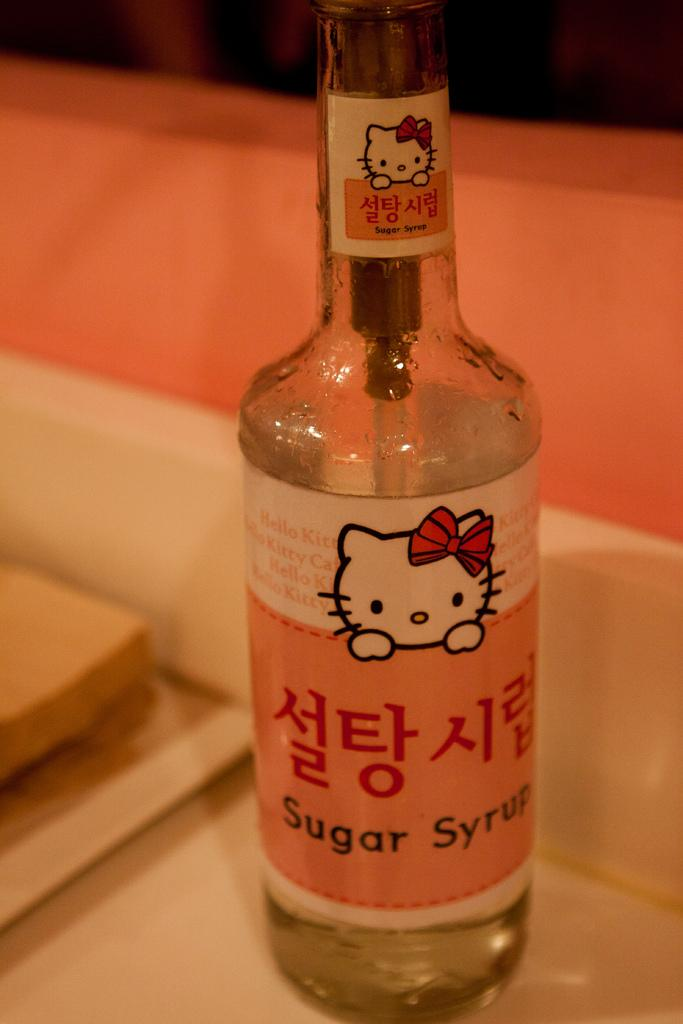Provide a one-sentence caption for the provided image. A clear bottle of sugar syrup with a Hello Kitty label and Asian writing. 